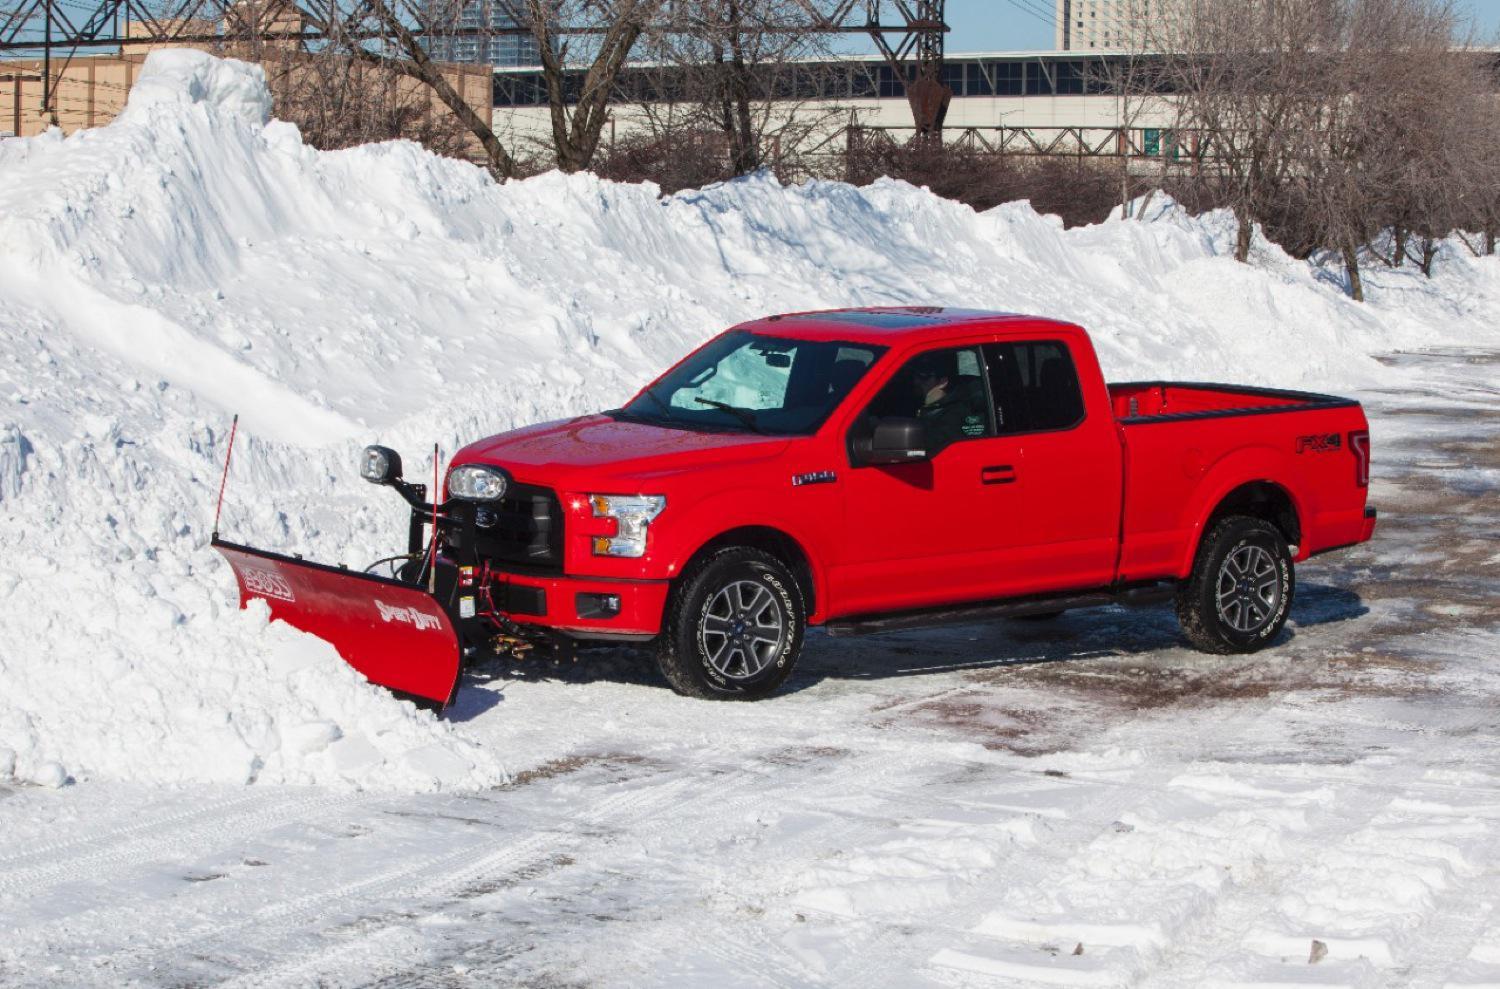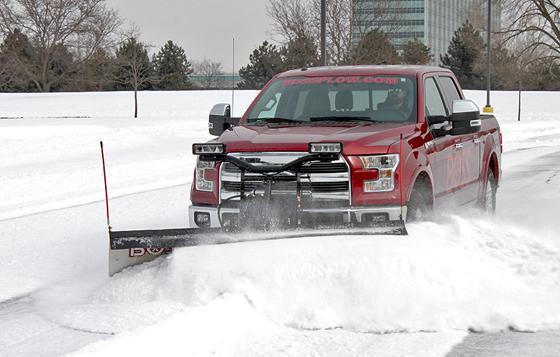The first image is the image on the left, the second image is the image on the right. Examine the images to the left and right. Is the description "One or more of the plows shown are pushing snow." accurate? Answer yes or no. Yes. The first image is the image on the left, the second image is the image on the right. Analyze the images presented: Is the assertion "Right image shows a red truck with its plow pushing up snow." valid? Answer yes or no. Yes. 